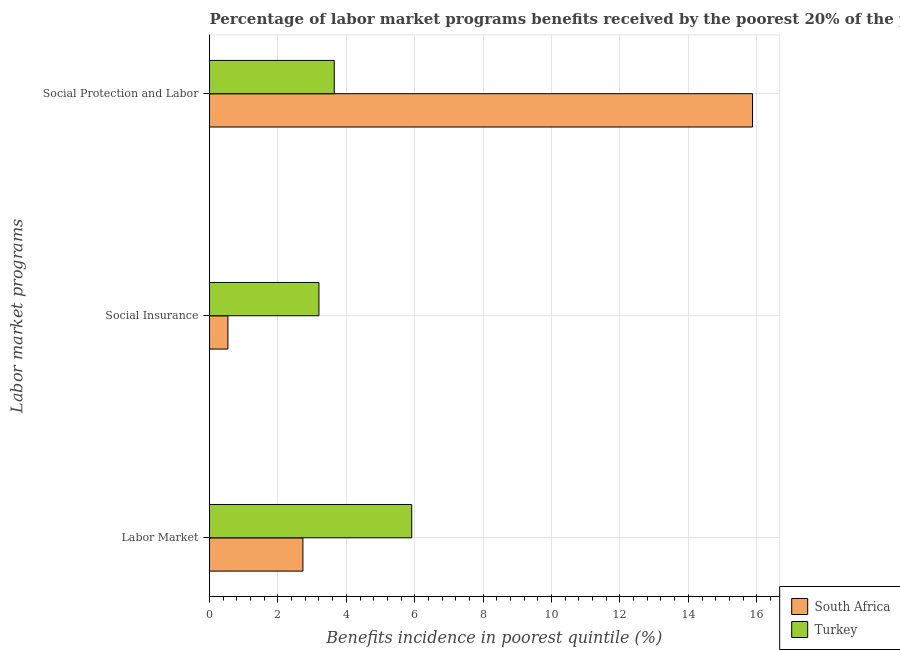How many different coloured bars are there?
Offer a very short reply. 2. Are the number of bars per tick equal to the number of legend labels?
Provide a succinct answer. Yes. How many bars are there on the 3rd tick from the bottom?
Offer a terse response. 2. What is the label of the 2nd group of bars from the top?
Ensure brevity in your answer.  Social Insurance. What is the percentage of benefits received due to social protection programs in Turkey?
Offer a very short reply. 3.65. Across all countries, what is the maximum percentage of benefits received due to labor market programs?
Offer a very short reply. 5.91. Across all countries, what is the minimum percentage of benefits received due to social protection programs?
Offer a very short reply. 3.65. In which country was the percentage of benefits received due to social protection programs maximum?
Provide a short and direct response. South Africa. In which country was the percentage of benefits received due to labor market programs minimum?
Your answer should be compact. South Africa. What is the total percentage of benefits received due to social protection programs in the graph?
Your answer should be very brief. 19.52. What is the difference between the percentage of benefits received due to social insurance programs in Turkey and that in South Africa?
Make the answer very short. 2.66. What is the difference between the percentage of benefits received due to social protection programs in Turkey and the percentage of benefits received due to social insurance programs in South Africa?
Provide a succinct answer. 3.11. What is the average percentage of benefits received due to labor market programs per country?
Keep it short and to the point. 4.32. What is the difference between the percentage of benefits received due to social protection programs and percentage of benefits received due to labor market programs in Turkey?
Provide a short and direct response. -2.27. In how many countries, is the percentage of benefits received due to social insurance programs greater than 7.2 %?
Give a very brief answer. 0. What is the ratio of the percentage of benefits received due to social protection programs in South Africa to that in Turkey?
Your answer should be very brief. 4.35. Is the percentage of benefits received due to social protection programs in Turkey less than that in South Africa?
Provide a short and direct response. Yes. Is the difference between the percentage of benefits received due to social protection programs in Turkey and South Africa greater than the difference between the percentage of benefits received due to social insurance programs in Turkey and South Africa?
Provide a short and direct response. No. What is the difference between the highest and the second highest percentage of benefits received due to labor market programs?
Provide a succinct answer. 3.18. What is the difference between the highest and the lowest percentage of benefits received due to labor market programs?
Your response must be concise. 3.18. In how many countries, is the percentage of benefits received due to social protection programs greater than the average percentage of benefits received due to social protection programs taken over all countries?
Offer a very short reply. 1. Is the sum of the percentage of benefits received due to social insurance programs in South Africa and Turkey greater than the maximum percentage of benefits received due to labor market programs across all countries?
Keep it short and to the point. No. What does the 2nd bar from the top in Social Insurance represents?
Your response must be concise. South Africa. What does the 2nd bar from the bottom in Social Protection and Labor represents?
Your answer should be compact. Turkey. How many bars are there?
Your answer should be very brief. 6. Are all the bars in the graph horizontal?
Offer a very short reply. Yes. Are the values on the major ticks of X-axis written in scientific E-notation?
Give a very brief answer. No. Does the graph contain any zero values?
Offer a terse response. No. Where does the legend appear in the graph?
Ensure brevity in your answer.  Bottom right. What is the title of the graph?
Your answer should be compact. Percentage of labor market programs benefits received by the poorest 20% of the population of countries. Does "Bermuda" appear as one of the legend labels in the graph?
Offer a terse response. No. What is the label or title of the X-axis?
Provide a succinct answer. Benefits incidence in poorest quintile (%). What is the label or title of the Y-axis?
Your answer should be very brief. Labor market programs. What is the Benefits incidence in poorest quintile (%) of South Africa in Labor Market?
Offer a very short reply. 2.73. What is the Benefits incidence in poorest quintile (%) of Turkey in Labor Market?
Provide a short and direct response. 5.91. What is the Benefits incidence in poorest quintile (%) in South Africa in Social Insurance?
Your answer should be compact. 0.54. What is the Benefits incidence in poorest quintile (%) in Turkey in Social Insurance?
Your answer should be very brief. 3.2. What is the Benefits incidence in poorest quintile (%) of South Africa in Social Protection and Labor?
Keep it short and to the point. 15.88. What is the Benefits incidence in poorest quintile (%) in Turkey in Social Protection and Labor?
Offer a terse response. 3.65. Across all Labor market programs, what is the maximum Benefits incidence in poorest quintile (%) of South Africa?
Ensure brevity in your answer.  15.88. Across all Labor market programs, what is the maximum Benefits incidence in poorest quintile (%) of Turkey?
Your answer should be very brief. 5.91. Across all Labor market programs, what is the minimum Benefits incidence in poorest quintile (%) in South Africa?
Ensure brevity in your answer.  0.54. Across all Labor market programs, what is the minimum Benefits incidence in poorest quintile (%) of Turkey?
Ensure brevity in your answer.  3.2. What is the total Benefits incidence in poorest quintile (%) of South Africa in the graph?
Ensure brevity in your answer.  19.14. What is the total Benefits incidence in poorest quintile (%) in Turkey in the graph?
Give a very brief answer. 12.76. What is the difference between the Benefits incidence in poorest quintile (%) in South Africa in Labor Market and that in Social Insurance?
Offer a terse response. 2.19. What is the difference between the Benefits incidence in poorest quintile (%) of Turkey in Labor Market and that in Social Insurance?
Offer a terse response. 2.71. What is the difference between the Benefits incidence in poorest quintile (%) in South Africa in Labor Market and that in Social Protection and Labor?
Give a very brief answer. -13.15. What is the difference between the Benefits incidence in poorest quintile (%) in Turkey in Labor Market and that in Social Protection and Labor?
Provide a short and direct response. 2.27. What is the difference between the Benefits incidence in poorest quintile (%) in South Africa in Social Insurance and that in Social Protection and Labor?
Provide a short and direct response. -15.34. What is the difference between the Benefits incidence in poorest quintile (%) in Turkey in Social Insurance and that in Social Protection and Labor?
Ensure brevity in your answer.  -0.45. What is the difference between the Benefits incidence in poorest quintile (%) of South Africa in Labor Market and the Benefits incidence in poorest quintile (%) of Turkey in Social Insurance?
Your response must be concise. -0.47. What is the difference between the Benefits incidence in poorest quintile (%) of South Africa in Labor Market and the Benefits incidence in poorest quintile (%) of Turkey in Social Protection and Labor?
Give a very brief answer. -0.92. What is the difference between the Benefits incidence in poorest quintile (%) in South Africa in Social Insurance and the Benefits incidence in poorest quintile (%) in Turkey in Social Protection and Labor?
Keep it short and to the point. -3.11. What is the average Benefits incidence in poorest quintile (%) in South Africa per Labor market programs?
Keep it short and to the point. 6.38. What is the average Benefits incidence in poorest quintile (%) in Turkey per Labor market programs?
Your answer should be compact. 4.25. What is the difference between the Benefits incidence in poorest quintile (%) of South Africa and Benefits incidence in poorest quintile (%) of Turkey in Labor Market?
Provide a short and direct response. -3.18. What is the difference between the Benefits incidence in poorest quintile (%) of South Africa and Benefits incidence in poorest quintile (%) of Turkey in Social Insurance?
Ensure brevity in your answer.  -2.66. What is the difference between the Benefits incidence in poorest quintile (%) of South Africa and Benefits incidence in poorest quintile (%) of Turkey in Social Protection and Labor?
Your answer should be very brief. 12.23. What is the ratio of the Benefits incidence in poorest quintile (%) of South Africa in Labor Market to that in Social Insurance?
Offer a very short reply. 5.09. What is the ratio of the Benefits incidence in poorest quintile (%) in Turkey in Labor Market to that in Social Insurance?
Offer a very short reply. 1.85. What is the ratio of the Benefits incidence in poorest quintile (%) in South Africa in Labor Market to that in Social Protection and Labor?
Offer a very short reply. 0.17. What is the ratio of the Benefits incidence in poorest quintile (%) in Turkey in Labor Market to that in Social Protection and Labor?
Provide a succinct answer. 1.62. What is the ratio of the Benefits incidence in poorest quintile (%) in South Africa in Social Insurance to that in Social Protection and Labor?
Give a very brief answer. 0.03. What is the ratio of the Benefits incidence in poorest quintile (%) of Turkey in Social Insurance to that in Social Protection and Labor?
Your response must be concise. 0.88. What is the difference between the highest and the second highest Benefits incidence in poorest quintile (%) of South Africa?
Provide a short and direct response. 13.15. What is the difference between the highest and the second highest Benefits incidence in poorest quintile (%) in Turkey?
Offer a very short reply. 2.27. What is the difference between the highest and the lowest Benefits incidence in poorest quintile (%) in South Africa?
Give a very brief answer. 15.34. What is the difference between the highest and the lowest Benefits incidence in poorest quintile (%) in Turkey?
Make the answer very short. 2.71. 